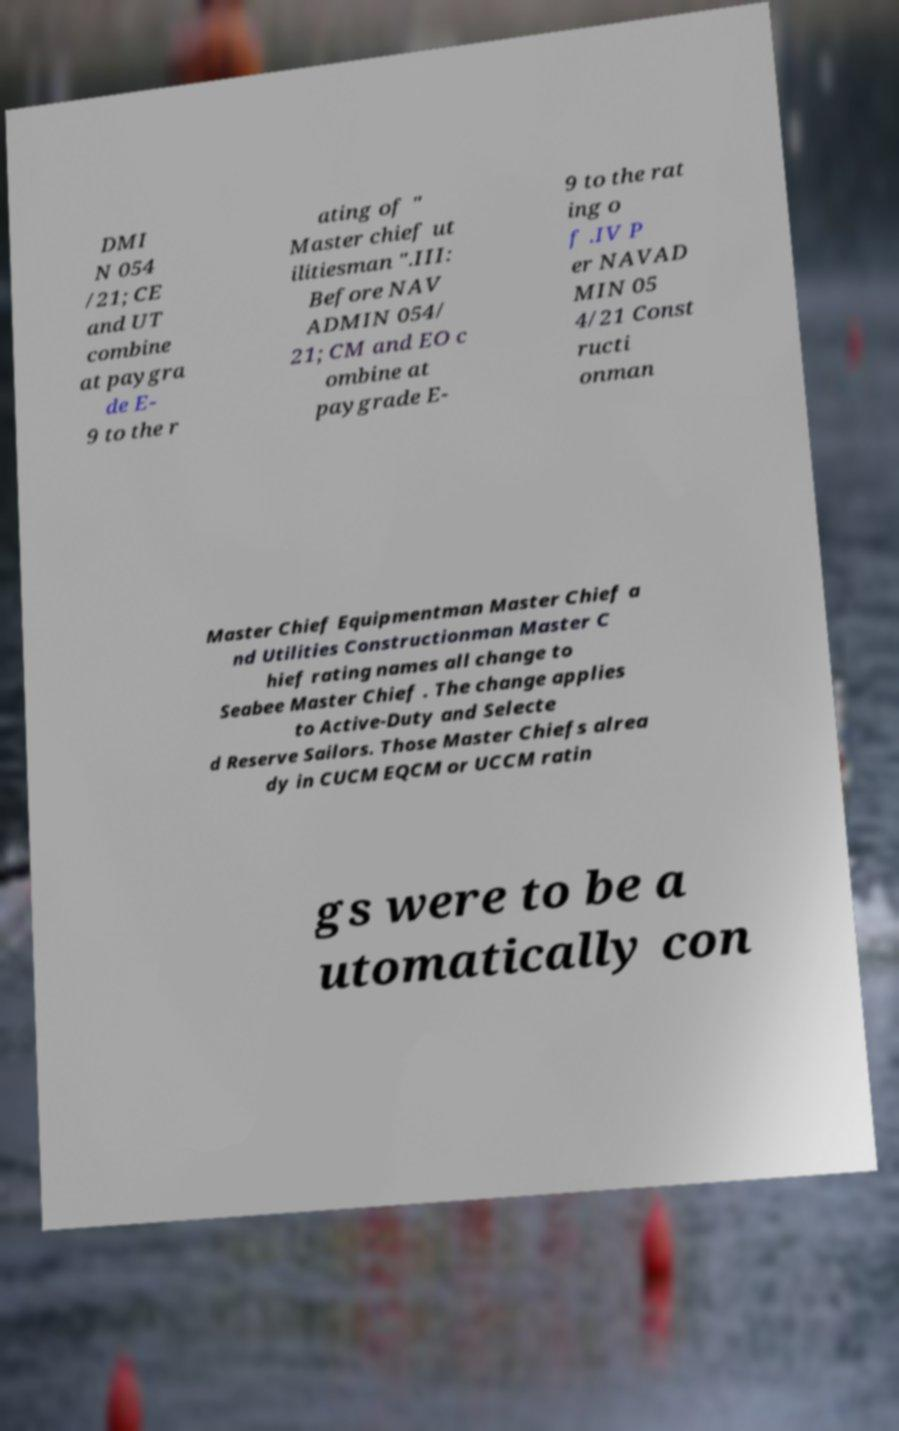There's text embedded in this image that I need extracted. Can you transcribe it verbatim? DMI N 054 /21; CE and UT combine at paygra de E- 9 to the r ating of " Master chief ut ilitiesman ".III: Before NAV ADMIN 054/ 21; CM and EO c ombine at paygrade E- 9 to the rat ing o f .IV P er NAVAD MIN 05 4/21 Const ructi onman Master Chief Equipmentman Master Chief a nd Utilities Constructionman Master C hief rating names all change to Seabee Master Chief . The change applies to Active-Duty and Selecte d Reserve Sailors. Those Master Chiefs alrea dy in CUCM EQCM or UCCM ratin gs were to be a utomatically con 